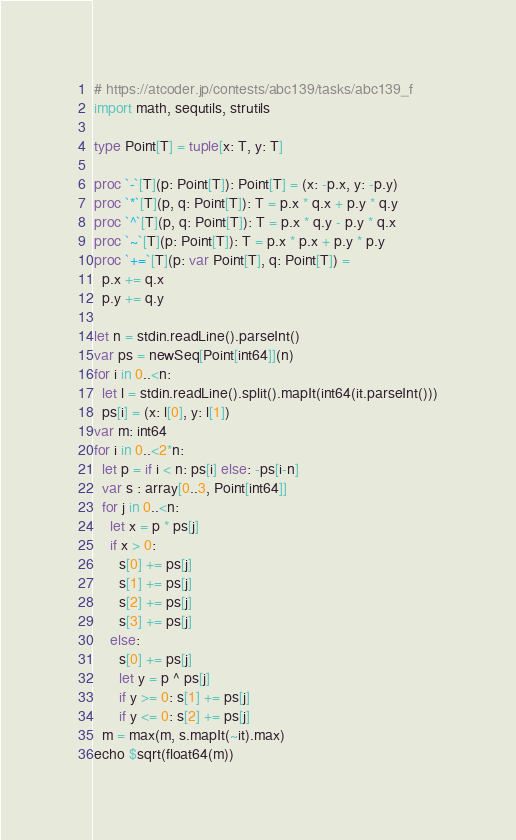Convert code to text. <code><loc_0><loc_0><loc_500><loc_500><_Nim_># https://atcoder.jp/contests/abc139/tasks/abc139_f
import math, sequtils, strutils

type Point[T] = tuple[x: T, y: T]

proc `-`[T](p: Point[T]): Point[T] = (x: -p.x, y: -p.y)
proc `*`[T](p, q: Point[T]): T = p.x * q.x + p.y * q.y
proc `^`[T](p, q: Point[T]): T = p.x * q.y - p.y * q.x
proc `~`[T](p: Point[T]): T = p.x * p.x + p.y * p.y
proc `+=`[T](p: var Point[T], q: Point[T]) =
  p.x += q.x
  p.y += q.y

let n = stdin.readLine().parseInt()
var ps = newSeq[Point[int64]](n)
for i in 0..<n:
  let l = stdin.readLine().split().mapIt(int64(it.parseInt()))
  ps[i] = (x: l[0], y: l[1])
var m: int64
for i in 0..<2*n:
  let p = if i < n: ps[i] else: -ps[i-n]
  var s : array[0..3, Point[int64]]
  for j in 0..<n:
    let x = p * ps[j]
    if x > 0:
      s[0] += ps[j]
      s[1] += ps[j]
      s[2] += ps[j]
      s[3] += ps[j]
    else:
      s[0] += ps[j]
      let y = p ^ ps[j]
      if y >= 0: s[1] += ps[j]
      if y <= 0: s[2] += ps[j]
  m = max(m, s.mapIt(~it).max)
echo $sqrt(float64(m))
</code> 